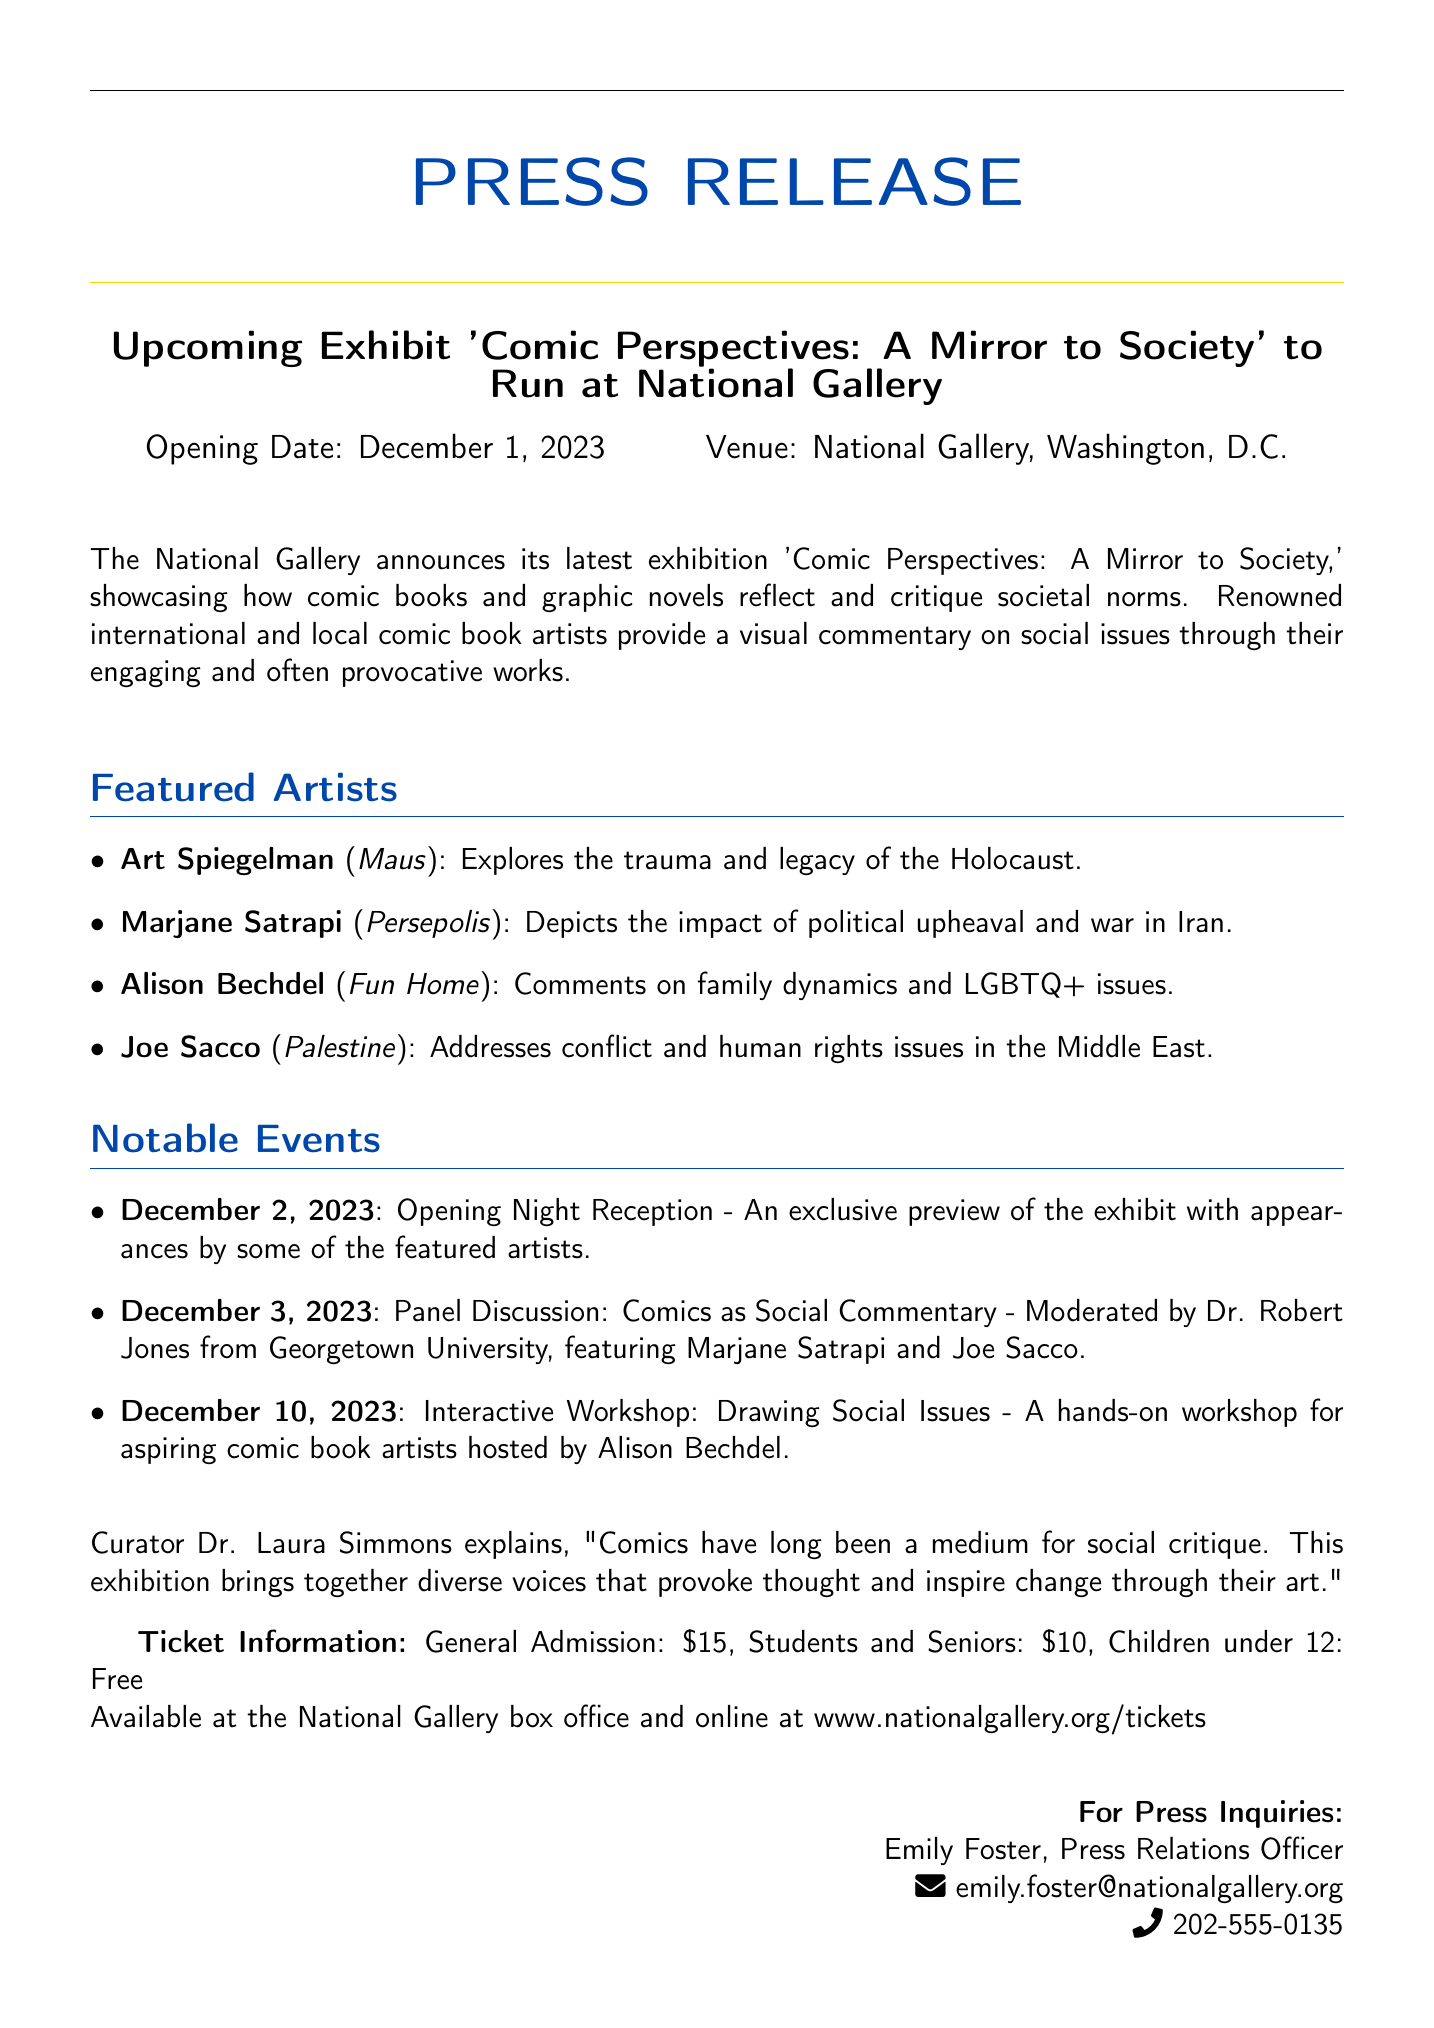What is the opening date of the exhibit? The opening date is mentioned in the press release as December 1, 2023.
Answer: December 1, 2023 Who is the curator of the exhibit? The curator is identified as Dr. Laura Simmons in the document.
Answer: Dr. Laura Simmons What is the general admission price for the exhibit? The document states the general admission price as $15.
Answer: $15 What notable event is scheduled for December 3, 2023? The event scheduled for December 3, 2023, is a Panel Discussion: Comics as Social Commentary.
Answer: Panel Discussion: Comics as Social Commentary Which artist's work explores the trauma of the Holocaust? The document specifies Art Spiegelman as the artist exploring that theme through his work.
Answer: Art Spiegelman How many featured artists are listed in the document? There are four featured artists mentioned in the press release.
Answer: Four What is the theme of the exhibit? The theme of the exhibit is how comic books and graphic novels reflect and critique societal norms.
Answer: Reflect and critique societal norms What type of workshop is being held on December 10, 2023? The workshop being held is a hands-on workshop for aspiring comic book artists.
Answer: Hands-on workshop for aspiring comic book artists 